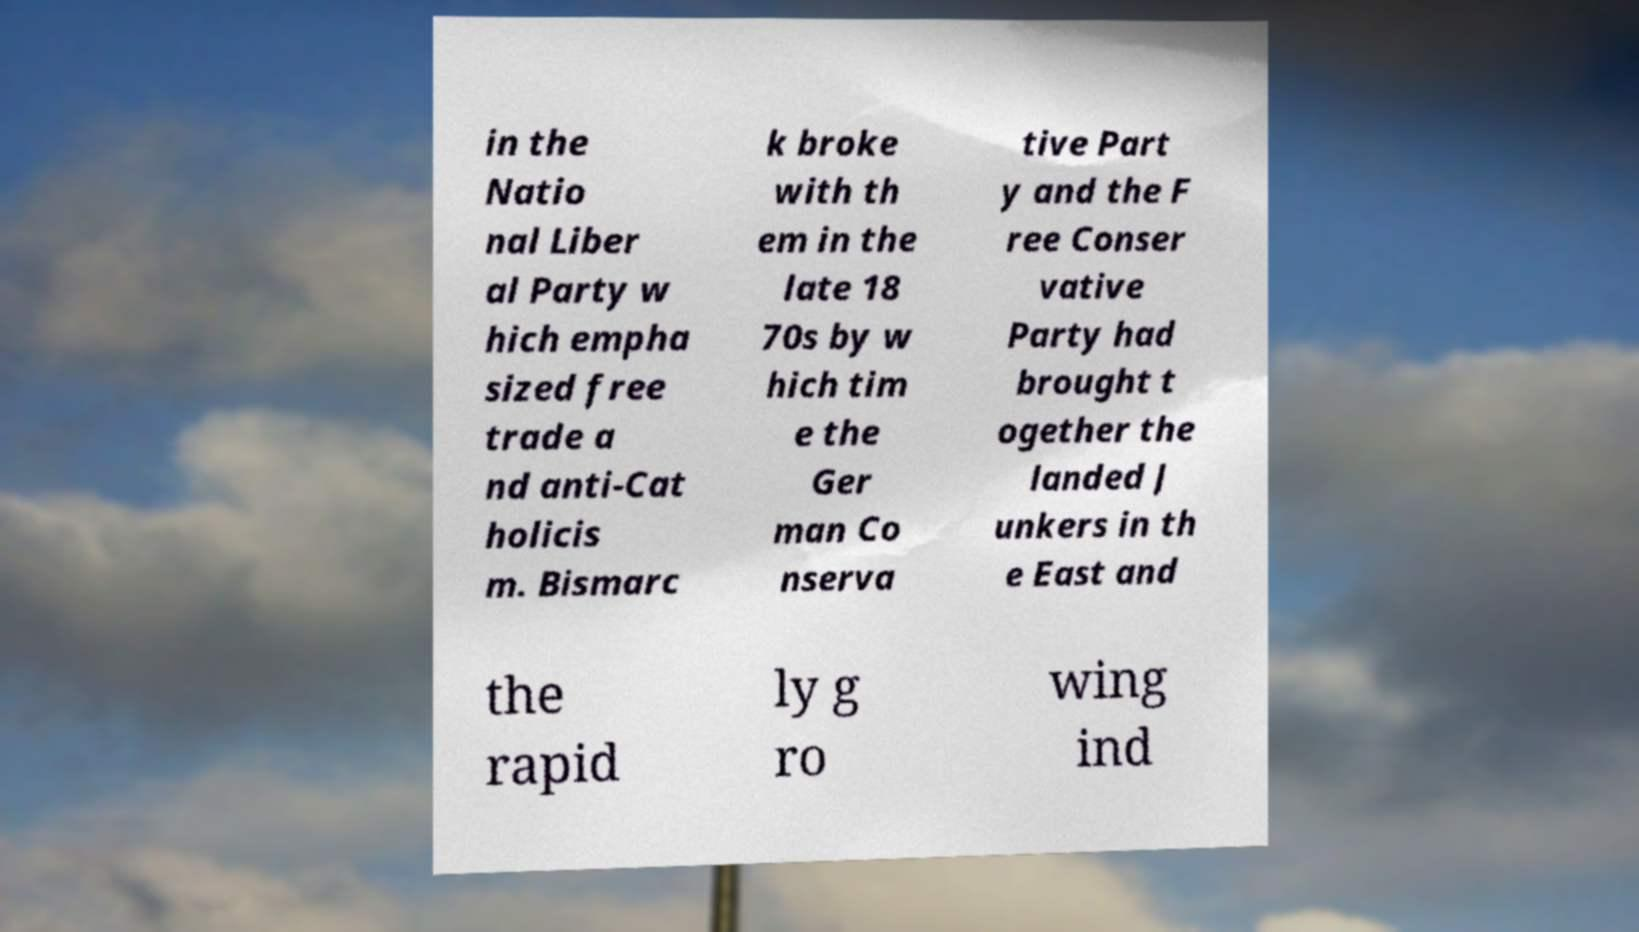Can you accurately transcribe the text from the provided image for me? in the Natio nal Liber al Party w hich empha sized free trade a nd anti-Cat holicis m. Bismarc k broke with th em in the late 18 70s by w hich tim e the Ger man Co nserva tive Part y and the F ree Conser vative Party had brought t ogether the landed J unkers in th e East and the rapid ly g ro wing ind 